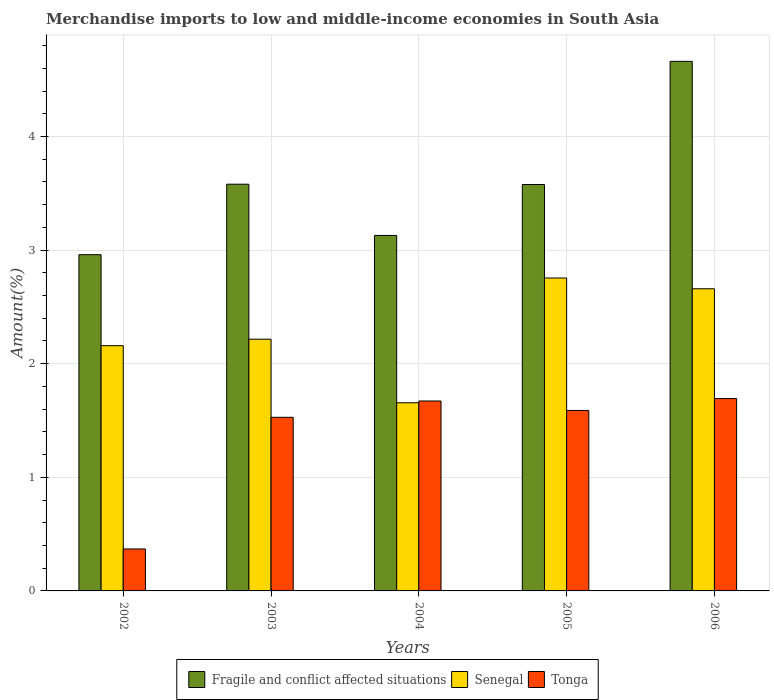How many different coloured bars are there?
Ensure brevity in your answer.  3. How many groups of bars are there?
Make the answer very short. 5. Are the number of bars per tick equal to the number of legend labels?
Provide a succinct answer. Yes. How many bars are there on the 2nd tick from the left?
Your answer should be compact. 3. How many bars are there on the 2nd tick from the right?
Give a very brief answer. 3. What is the label of the 3rd group of bars from the left?
Offer a terse response. 2004. What is the percentage of amount earned from merchandise imports in Senegal in 2002?
Make the answer very short. 2.16. Across all years, what is the maximum percentage of amount earned from merchandise imports in Tonga?
Provide a short and direct response. 1.69. Across all years, what is the minimum percentage of amount earned from merchandise imports in Senegal?
Ensure brevity in your answer.  1.66. In which year was the percentage of amount earned from merchandise imports in Tonga minimum?
Ensure brevity in your answer.  2002. What is the total percentage of amount earned from merchandise imports in Fragile and conflict affected situations in the graph?
Give a very brief answer. 17.91. What is the difference between the percentage of amount earned from merchandise imports in Fragile and conflict affected situations in 2002 and that in 2005?
Your response must be concise. -0.62. What is the difference between the percentage of amount earned from merchandise imports in Senegal in 2003 and the percentage of amount earned from merchandise imports in Tonga in 2006?
Offer a very short reply. 0.52. What is the average percentage of amount earned from merchandise imports in Tonga per year?
Provide a short and direct response. 1.37. In the year 2005, what is the difference between the percentage of amount earned from merchandise imports in Senegal and percentage of amount earned from merchandise imports in Fragile and conflict affected situations?
Your response must be concise. -0.82. What is the ratio of the percentage of amount earned from merchandise imports in Tonga in 2002 to that in 2004?
Provide a short and direct response. 0.22. Is the percentage of amount earned from merchandise imports in Tonga in 2004 less than that in 2005?
Provide a succinct answer. No. What is the difference between the highest and the second highest percentage of amount earned from merchandise imports in Tonga?
Your answer should be compact. 0.02. What is the difference between the highest and the lowest percentage of amount earned from merchandise imports in Fragile and conflict affected situations?
Offer a very short reply. 1.7. What does the 3rd bar from the left in 2003 represents?
Keep it short and to the point. Tonga. What does the 2nd bar from the right in 2006 represents?
Give a very brief answer. Senegal. Is it the case that in every year, the sum of the percentage of amount earned from merchandise imports in Senegal and percentage of amount earned from merchandise imports in Tonga is greater than the percentage of amount earned from merchandise imports in Fragile and conflict affected situations?
Your answer should be very brief. No. How many bars are there?
Ensure brevity in your answer.  15. What is the difference between two consecutive major ticks on the Y-axis?
Offer a terse response. 1. Are the values on the major ticks of Y-axis written in scientific E-notation?
Offer a very short reply. No. Does the graph contain any zero values?
Keep it short and to the point. No. Where does the legend appear in the graph?
Your response must be concise. Bottom center. How many legend labels are there?
Offer a terse response. 3. What is the title of the graph?
Provide a succinct answer. Merchandise imports to low and middle-income economies in South Asia. What is the label or title of the X-axis?
Provide a succinct answer. Years. What is the label or title of the Y-axis?
Provide a succinct answer. Amount(%). What is the Amount(%) of Fragile and conflict affected situations in 2002?
Make the answer very short. 2.96. What is the Amount(%) of Senegal in 2002?
Make the answer very short. 2.16. What is the Amount(%) in Tonga in 2002?
Offer a very short reply. 0.37. What is the Amount(%) in Fragile and conflict affected situations in 2003?
Offer a very short reply. 3.58. What is the Amount(%) in Senegal in 2003?
Ensure brevity in your answer.  2.22. What is the Amount(%) of Tonga in 2003?
Make the answer very short. 1.53. What is the Amount(%) of Fragile and conflict affected situations in 2004?
Your answer should be very brief. 3.13. What is the Amount(%) of Senegal in 2004?
Make the answer very short. 1.66. What is the Amount(%) in Tonga in 2004?
Provide a short and direct response. 1.67. What is the Amount(%) of Fragile and conflict affected situations in 2005?
Provide a succinct answer. 3.58. What is the Amount(%) of Senegal in 2005?
Your response must be concise. 2.75. What is the Amount(%) in Tonga in 2005?
Make the answer very short. 1.59. What is the Amount(%) of Fragile and conflict affected situations in 2006?
Offer a terse response. 4.66. What is the Amount(%) of Senegal in 2006?
Offer a very short reply. 2.66. What is the Amount(%) in Tonga in 2006?
Your answer should be very brief. 1.69. Across all years, what is the maximum Amount(%) in Fragile and conflict affected situations?
Give a very brief answer. 4.66. Across all years, what is the maximum Amount(%) in Senegal?
Provide a short and direct response. 2.75. Across all years, what is the maximum Amount(%) of Tonga?
Your answer should be compact. 1.69. Across all years, what is the minimum Amount(%) of Fragile and conflict affected situations?
Your answer should be compact. 2.96. Across all years, what is the minimum Amount(%) of Senegal?
Provide a succinct answer. 1.66. Across all years, what is the minimum Amount(%) of Tonga?
Provide a short and direct response. 0.37. What is the total Amount(%) of Fragile and conflict affected situations in the graph?
Make the answer very short. 17.91. What is the total Amount(%) of Senegal in the graph?
Make the answer very short. 11.44. What is the total Amount(%) in Tonga in the graph?
Your answer should be compact. 6.85. What is the difference between the Amount(%) of Fragile and conflict affected situations in 2002 and that in 2003?
Your answer should be compact. -0.62. What is the difference between the Amount(%) in Senegal in 2002 and that in 2003?
Your answer should be compact. -0.06. What is the difference between the Amount(%) in Tonga in 2002 and that in 2003?
Provide a succinct answer. -1.16. What is the difference between the Amount(%) of Fragile and conflict affected situations in 2002 and that in 2004?
Keep it short and to the point. -0.17. What is the difference between the Amount(%) in Senegal in 2002 and that in 2004?
Your answer should be compact. 0.5. What is the difference between the Amount(%) in Tonga in 2002 and that in 2004?
Offer a very short reply. -1.3. What is the difference between the Amount(%) of Fragile and conflict affected situations in 2002 and that in 2005?
Provide a short and direct response. -0.62. What is the difference between the Amount(%) in Senegal in 2002 and that in 2005?
Offer a very short reply. -0.6. What is the difference between the Amount(%) in Tonga in 2002 and that in 2005?
Offer a very short reply. -1.22. What is the difference between the Amount(%) of Fragile and conflict affected situations in 2002 and that in 2006?
Provide a short and direct response. -1.7. What is the difference between the Amount(%) of Senegal in 2002 and that in 2006?
Give a very brief answer. -0.5. What is the difference between the Amount(%) of Tonga in 2002 and that in 2006?
Provide a succinct answer. -1.32. What is the difference between the Amount(%) of Fragile and conflict affected situations in 2003 and that in 2004?
Give a very brief answer. 0.45. What is the difference between the Amount(%) in Senegal in 2003 and that in 2004?
Your answer should be compact. 0.56. What is the difference between the Amount(%) in Tonga in 2003 and that in 2004?
Offer a terse response. -0.14. What is the difference between the Amount(%) in Fragile and conflict affected situations in 2003 and that in 2005?
Your answer should be compact. 0. What is the difference between the Amount(%) of Senegal in 2003 and that in 2005?
Keep it short and to the point. -0.54. What is the difference between the Amount(%) of Tonga in 2003 and that in 2005?
Give a very brief answer. -0.06. What is the difference between the Amount(%) in Fragile and conflict affected situations in 2003 and that in 2006?
Provide a succinct answer. -1.08. What is the difference between the Amount(%) of Senegal in 2003 and that in 2006?
Keep it short and to the point. -0.44. What is the difference between the Amount(%) in Tonga in 2003 and that in 2006?
Keep it short and to the point. -0.16. What is the difference between the Amount(%) in Fragile and conflict affected situations in 2004 and that in 2005?
Make the answer very short. -0.45. What is the difference between the Amount(%) in Senegal in 2004 and that in 2005?
Offer a terse response. -1.1. What is the difference between the Amount(%) of Tonga in 2004 and that in 2005?
Make the answer very short. 0.08. What is the difference between the Amount(%) in Fragile and conflict affected situations in 2004 and that in 2006?
Offer a terse response. -1.53. What is the difference between the Amount(%) of Senegal in 2004 and that in 2006?
Your answer should be compact. -1. What is the difference between the Amount(%) in Tonga in 2004 and that in 2006?
Keep it short and to the point. -0.02. What is the difference between the Amount(%) in Fragile and conflict affected situations in 2005 and that in 2006?
Your answer should be very brief. -1.08. What is the difference between the Amount(%) of Senegal in 2005 and that in 2006?
Keep it short and to the point. 0.09. What is the difference between the Amount(%) of Tonga in 2005 and that in 2006?
Offer a terse response. -0.1. What is the difference between the Amount(%) of Fragile and conflict affected situations in 2002 and the Amount(%) of Senegal in 2003?
Provide a succinct answer. 0.74. What is the difference between the Amount(%) of Fragile and conflict affected situations in 2002 and the Amount(%) of Tonga in 2003?
Offer a very short reply. 1.43. What is the difference between the Amount(%) of Senegal in 2002 and the Amount(%) of Tonga in 2003?
Offer a terse response. 0.63. What is the difference between the Amount(%) of Fragile and conflict affected situations in 2002 and the Amount(%) of Senegal in 2004?
Your response must be concise. 1.3. What is the difference between the Amount(%) of Fragile and conflict affected situations in 2002 and the Amount(%) of Tonga in 2004?
Your answer should be very brief. 1.29. What is the difference between the Amount(%) in Senegal in 2002 and the Amount(%) in Tonga in 2004?
Provide a short and direct response. 0.49. What is the difference between the Amount(%) of Fragile and conflict affected situations in 2002 and the Amount(%) of Senegal in 2005?
Offer a terse response. 0.21. What is the difference between the Amount(%) in Fragile and conflict affected situations in 2002 and the Amount(%) in Tonga in 2005?
Your answer should be very brief. 1.37. What is the difference between the Amount(%) of Senegal in 2002 and the Amount(%) of Tonga in 2005?
Your response must be concise. 0.57. What is the difference between the Amount(%) in Fragile and conflict affected situations in 2002 and the Amount(%) in Senegal in 2006?
Your answer should be very brief. 0.3. What is the difference between the Amount(%) in Fragile and conflict affected situations in 2002 and the Amount(%) in Tonga in 2006?
Your answer should be compact. 1.27. What is the difference between the Amount(%) in Senegal in 2002 and the Amount(%) in Tonga in 2006?
Ensure brevity in your answer.  0.47. What is the difference between the Amount(%) in Fragile and conflict affected situations in 2003 and the Amount(%) in Senegal in 2004?
Your response must be concise. 1.92. What is the difference between the Amount(%) of Fragile and conflict affected situations in 2003 and the Amount(%) of Tonga in 2004?
Provide a succinct answer. 1.91. What is the difference between the Amount(%) in Senegal in 2003 and the Amount(%) in Tonga in 2004?
Ensure brevity in your answer.  0.54. What is the difference between the Amount(%) in Fragile and conflict affected situations in 2003 and the Amount(%) in Senegal in 2005?
Ensure brevity in your answer.  0.83. What is the difference between the Amount(%) in Fragile and conflict affected situations in 2003 and the Amount(%) in Tonga in 2005?
Offer a terse response. 1.99. What is the difference between the Amount(%) in Senegal in 2003 and the Amount(%) in Tonga in 2005?
Ensure brevity in your answer.  0.63. What is the difference between the Amount(%) in Fragile and conflict affected situations in 2003 and the Amount(%) in Senegal in 2006?
Make the answer very short. 0.92. What is the difference between the Amount(%) of Fragile and conflict affected situations in 2003 and the Amount(%) of Tonga in 2006?
Offer a very short reply. 1.89. What is the difference between the Amount(%) of Senegal in 2003 and the Amount(%) of Tonga in 2006?
Your response must be concise. 0.52. What is the difference between the Amount(%) of Fragile and conflict affected situations in 2004 and the Amount(%) of Senegal in 2005?
Keep it short and to the point. 0.37. What is the difference between the Amount(%) of Fragile and conflict affected situations in 2004 and the Amount(%) of Tonga in 2005?
Offer a terse response. 1.54. What is the difference between the Amount(%) in Senegal in 2004 and the Amount(%) in Tonga in 2005?
Offer a terse response. 0.07. What is the difference between the Amount(%) of Fragile and conflict affected situations in 2004 and the Amount(%) of Senegal in 2006?
Give a very brief answer. 0.47. What is the difference between the Amount(%) in Fragile and conflict affected situations in 2004 and the Amount(%) in Tonga in 2006?
Offer a terse response. 1.44. What is the difference between the Amount(%) of Senegal in 2004 and the Amount(%) of Tonga in 2006?
Your answer should be very brief. -0.04. What is the difference between the Amount(%) in Fragile and conflict affected situations in 2005 and the Amount(%) in Senegal in 2006?
Keep it short and to the point. 0.92. What is the difference between the Amount(%) of Fragile and conflict affected situations in 2005 and the Amount(%) of Tonga in 2006?
Make the answer very short. 1.88. What is the difference between the Amount(%) in Senegal in 2005 and the Amount(%) in Tonga in 2006?
Ensure brevity in your answer.  1.06. What is the average Amount(%) in Fragile and conflict affected situations per year?
Give a very brief answer. 3.58. What is the average Amount(%) in Senegal per year?
Your response must be concise. 2.29. What is the average Amount(%) of Tonga per year?
Your answer should be compact. 1.37. In the year 2002, what is the difference between the Amount(%) of Fragile and conflict affected situations and Amount(%) of Senegal?
Keep it short and to the point. 0.8. In the year 2002, what is the difference between the Amount(%) of Fragile and conflict affected situations and Amount(%) of Tonga?
Provide a succinct answer. 2.59. In the year 2002, what is the difference between the Amount(%) in Senegal and Amount(%) in Tonga?
Your answer should be compact. 1.79. In the year 2003, what is the difference between the Amount(%) of Fragile and conflict affected situations and Amount(%) of Senegal?
Provide a succinct answer. 1.36. In the year 2003, what is the difference between the Amount(%) of Fragile and conflict affected situations and Amount(%) of Tonga?
Ensure brevity in your answer.  2.05. In the year 2003, what is the difference between the Amount(%) of Senegal and Amount(%) of Tonga?
Your response must be concise. 0.69. In the year 2004, what is the difference between the Amount(%) of Fragile and conflict affected situations and Amount(%) of Senegal?
Keep it short and to the point. 1.47. In the year 2004, what is the difference between the Amount(%) in Fragile and conflict affected situations and Amount(%) in Tonga?
Your answer should be compact. 1.46. In the year 2004, what is the difference between the Amount(%) in Senegal and Amount(%) in Tonga?
Provide a short and direct response. -0.02. In the year 2005, what is the difference between the Amount(%) in Fragile and conflict affected situations and Amount(%) in Senegal?
Provide a short and direct response. 0.82. In the year 2005, what is the difference between the Amount(%) in Fragile and conflict affected situations and Amount(%) in Tonga?
Keep it short and to the point. 1.99. In the year 2005, what is the difference between the Amount(%) of Senegal and Amount(%) of Tonga?
Provide a succinct answer. 1.17. In the year 2006, what is the difference between the Amount(%) of Fragile and conflict affected situations and Amount(%) of Senegal?
Offer a terse response. 2. In the year 2006, what is the difference between the Amount(%) of Fragile and conflict affected situations and Amount(%) of Tonga?
Offer a very short reply. 2.97. In the year 2006, what is the difference between the Amount(%) of Senegal and Amount(%) of Tonga?
Ensure brevity in your answer.  0.97. What is the ratio of the Amount(%) in Fragile and conflict affected situations in 2002 to that in 2003?
Provide a succinct answer. 0.83. What is the ratio of the Amount(%) of Senegal in 2002 to that in 2003?
Offer a very short reply. 0.97. What is the ratio of the Amount(%) of Tonga in 2002 to that in 2003?
Your response must be concise. 0.24. What is the ratio of the Amount(%) of Fragile and conflict affected situations in 2002 to that in 2004?
Provide a succinct answer. 0.95. What is the ratio of the Amount(%) of Senegal in 2002 to that in 2004?
Provide a short and direct response. 1.3. What is the ratio of the Amount(%) of Tonga in 2002 to that in 2004?
Your answer should be very brief. 0.22. What is the ratio of the Amount(%) of Fragile and conflict affected situations in 2002 to that in 2005?
Offer a terse response. 0.83. What is the ratio of the Amount(%) of Senegal in 2002 to that in 2005?
Provide a succinct answer. 0.78. What is the ratio of the Amount(%) in Tonga in 2002 to that in 2005?
Make the answer very short. 0.23. What is the ratio of the Amount(%) of Fragile and conflict affected situations in 2002 to that in 2006?
Provide a succinct answer. 0.63. What is the ratio of the Amount(%) of Senegal in 2002 to that in 2006?
Provide a short and direct response. 0.81. What is the ratio of the Amount(%) of Tonga in 2002 to that in 2006?
Offer a very short reply. 0.22. What is the ratio of the Amount(%) of Fragile and conflict affected situations in 2003 to that in 2004?
Make the answer very short. 1.14. What is the ratio of the Amount(%) in Senegal in 2003 to that in 2004?
Provide a short and direct response. 1.34. What is the ratio of the Amount(%) of Tonga in 2003 to that in 2004?
Your answer should be very brief. 0.91. What is the ratio of the Amount(%) in Fragile and conflict affected situations in 2003 to that in 2005?
Make the answer very short. 1. What is the ratio of the Amount(%) in Senegal in 2003 to that in 2005?
Offer a very short reply. 0.8. What is the ratio of the Amount(%) of Tonga in 2003 to that in 2005?
Your response must be concise. 0.96. What is the ratio of the Amount(%) in Fragile and conflict affected situations in 2003 to that in 2006?
Make the answer very short. 0.77. What is the ratio of the Amount(%) of Senegal in 2003 to that in 2006?
Keep it short and to the point. 0.83. What is the ratio of the Amount(%) of Tonga in 2003 to that in 2006?
Ensure brevity in your answer.  0.9. What is the ratio of the Amount(%) in Fragile and conflict affected situations in 2004 to that in 2005?
Your response must be concise. 0.87. What is the ratio of the Amount(%) of Senegal in 2004 to that in 2005?
Your answer should be compact. 0.6. What is the ratio of the Amount(%) of Tonga in 2004 to that in 2005?
Ensure brevity in your answer.  1.05. What is the ratio of the Amount(%) in Fragile and conflict affected situations in 2004 to that in 2006?
Provide a short and direct response. 0.67. What is the ratio of the Amount(%) of Senegal in 2004 to that in 2006?
Give a very brief answer. 0.62. What is the ratio of the Amount(%) in Tonga in 2004 to that in 2006?
Provide a succinct answer. 0.99. What is the ratio of the Amount(%) of Fragile and conflict affected situations in 2005 to that in 2006?
Offer a terse response. 0.77. What is the ratio of the Amount(%) in Senegal in 2005 to that in 2006?
Make the answer very short. 1.04. What is the ratio of the Amount(%) of Tonga in 2005 to that in 2006?
Provide a short and direct response. 0.94. What is the difference between the highest and the second highest Amount(%) in Fragile and conflict affected situations?
Offer a very short reply. 1.08. What is the difference between the highest and the second highest Amount(%) in Senegal?
Keep it short and to the point. 0.09. What is the difference between the highest and the second highest Amount(%) of Tonga?
Keep it short and to the point. 0.02. What is the difference between the highest and the lowest Amount(%) in Fragile and conflict affected situations?
Offer a very short reply. 1.7. What is the difference between the highest and the lowest Amount(%) of Senegal?
Provide a succinct answer. 1.1. What is the difference between the highest and the lowest Amount(%) of Tonga?
Your answer should be very brief. 1.32. 